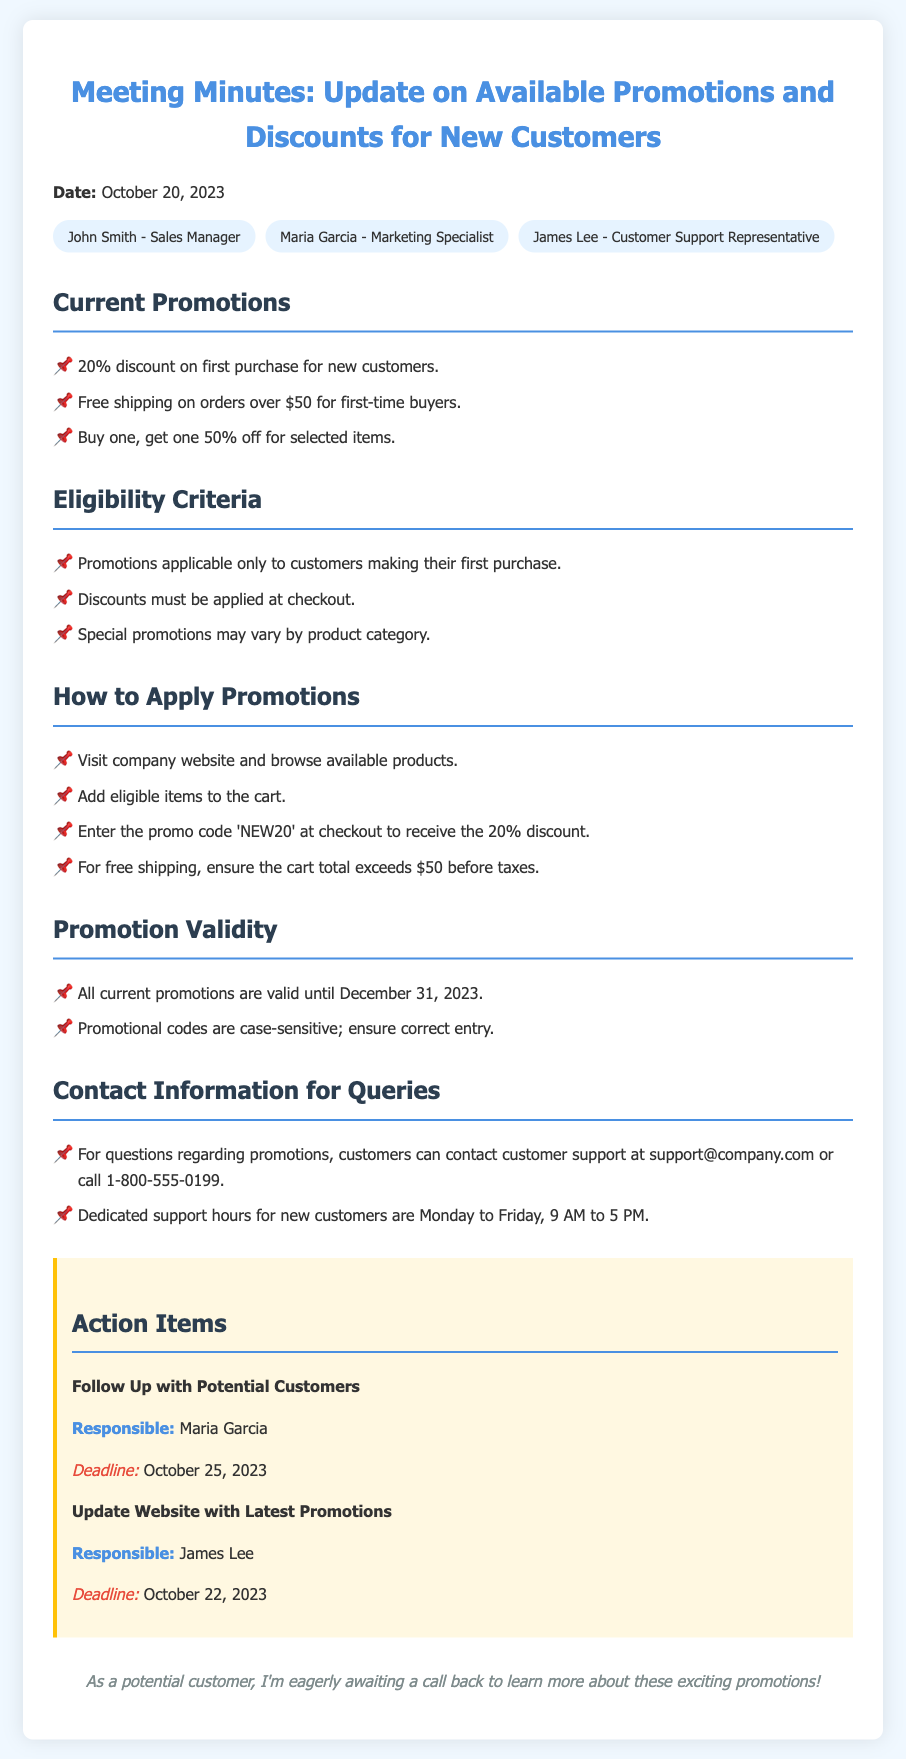What is the percentage discount for new customers' first purchase? The document states that there is a 20% discount on the first purchase for new customers.
Answer: 20% What is the minimum cart total for free shipping? The document mentions that free shipping applies on orders over $50.
Answer: $50 When do the current promotions expire? Promotions are valid until December 31, 2023, as noted in the document.
Answer: December 31, 2023 What is the promo code for the 20% discount? The document specifies that the promo code to receive the 20% discount at checkout is 'NEW20'.
Answer: NEW20 Who is responsible for following up with potential customers? According to the action items, Maria Garcia is responsible for this task.
Answer: Maria Garcia What is the contact email for queries about promotions? The document provides the contact email as support@company.com for any promotion related questions.
Answer: support@company.com What is required to receive the discount at checkout? The document states that discounts must be applied at checkout, specifically mentioning entering the promo code.
Answer: Entering the promo code What are the dedicated support hours for new customers? The document indicates that support hours for new customers are Monday to Friday, 9 AM to 5 PM.
Answer: Monday to Friday, 9 AM to 5 PM What discount is offered on selected items? It is mentioned in the document that there is a promotion of buy one, get one 50% off for selected items.
Answer: Buy one, get one 50% off 